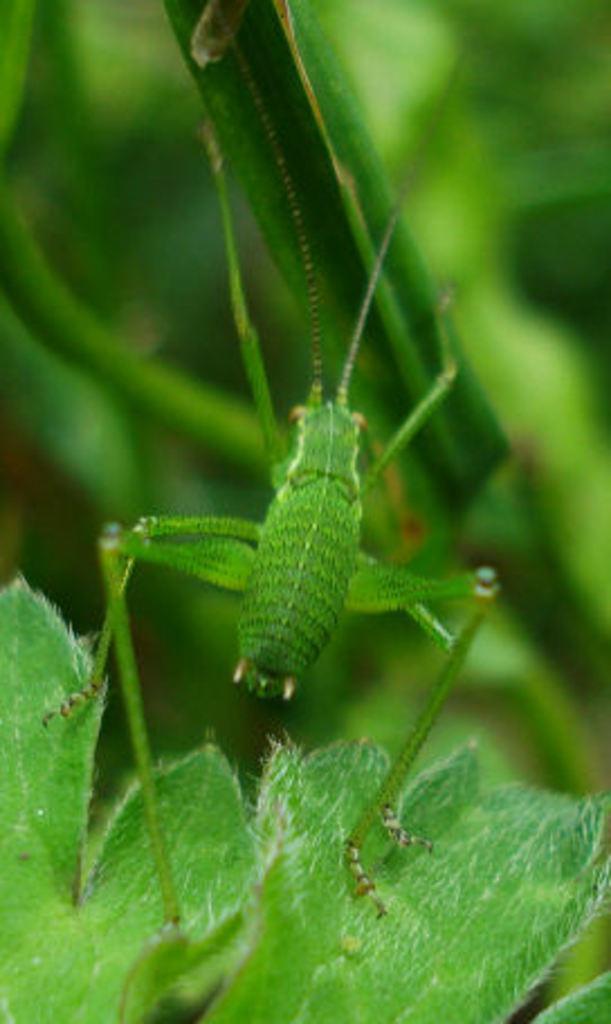How would you summarize this image in a sentence or two? In this image, we can see some leaves. There is an insect in the middle of the image. 